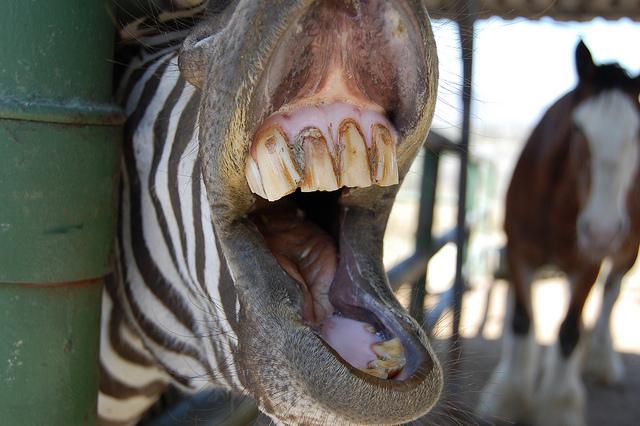Is the teeth clean?
Write a very short answer. No. Does this zebra floss?
Quick response, please. No. How many teeth is showing?
Concise answer only. 7. 